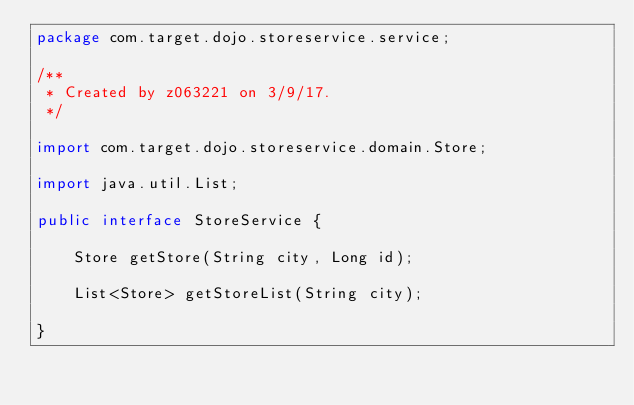<code> <loc_0><loc_0><loc_500><loc_500><_Java_>package com.target.dojo.storeservice.service;

/**
 * Created by z063221 on 3/9/17.
 */

import com.target.dojo.storeservice.domain.Store;

import java.util.List;

public interface StoreService {

    Store getStore(String city, Long id);

    List<Store> getStoreList(String city);

}</code> 